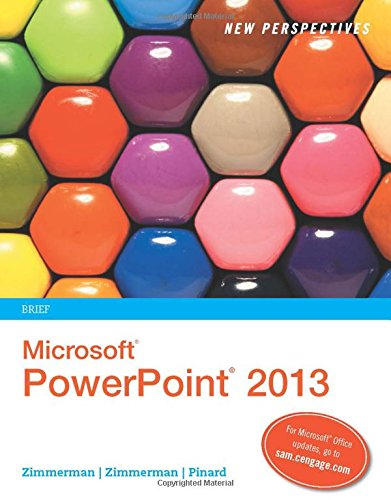Is this book related to Science & Math? No, this book is not related to Science & Math; it is strictly geared towards computers and technology education, particularly in relation to Microsoft PowerPoint. 